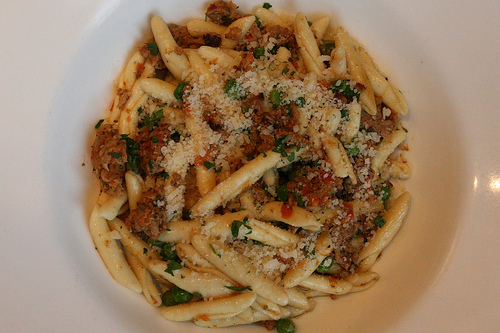<image>
Can you confirm if the noodles is under the bowl? No. The noodles is not positioned under the bowl. The vertical relationship between these objects is different. 